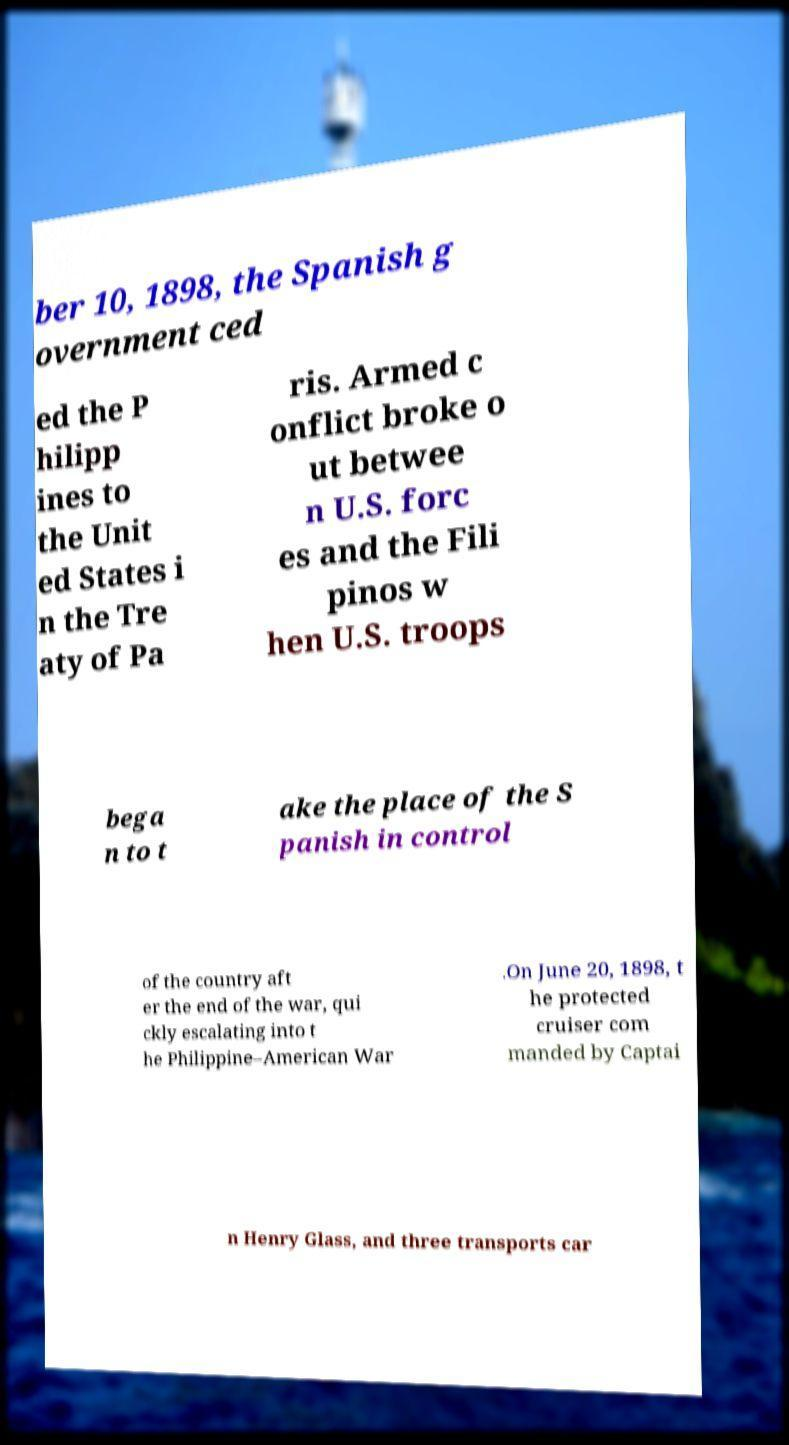Can you read and provide the text displayed in the image?This photo seems to have some interesting text. Can you extract and type it out for me? ber 10, 1898, the Spanish g overnment ced ed the P hilipp ines to the Unit ed States i n the Tre aty of Pa ris. Armed c onflict broke o ut betwee n U.S. forc es and the Fili pinos w hen U.S. troops bega n to t ake the place of the S panish in control of the country aft er the end of the war, qui ckly escalating into t he Philippine–American War .On June 20, 1898, t he protected cruiser com manded by Captai n Henry Glass, and three transports car 